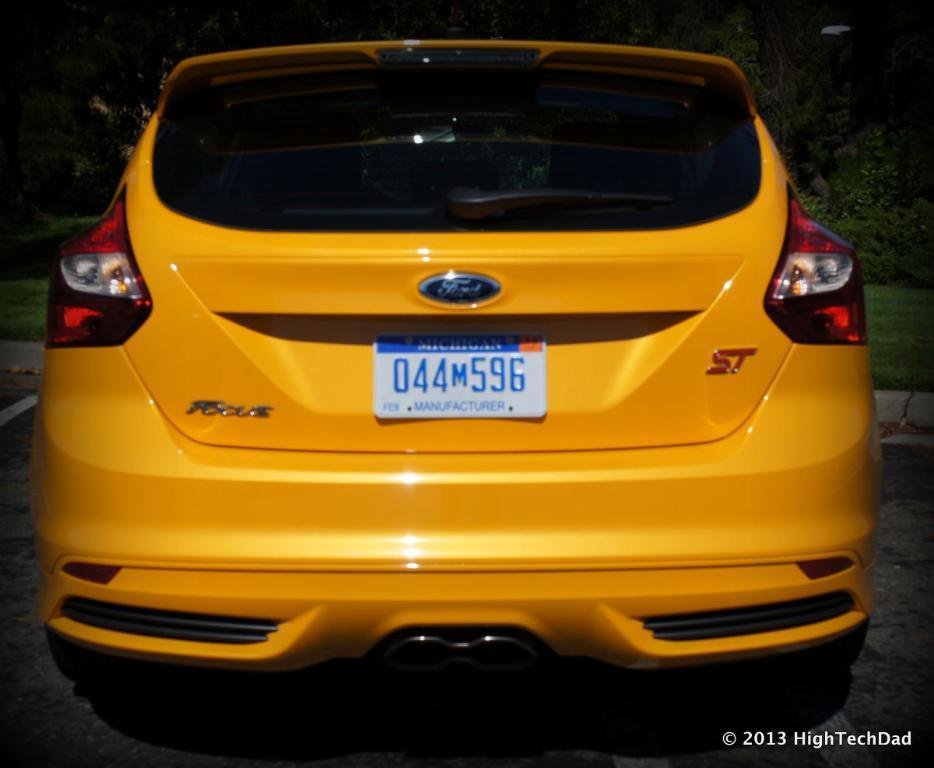Can you describe this image briefly? In this image in front there is a car parked on the road. In front of the car there's grass on the surface. In the background of the image there are trees and there is some text written on the right side of the image. 